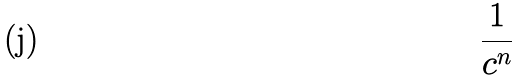<formula> <loc_0><loc_0><loc_500><loc_500>\frac { 1 } { c ^ { n } }</formula> 